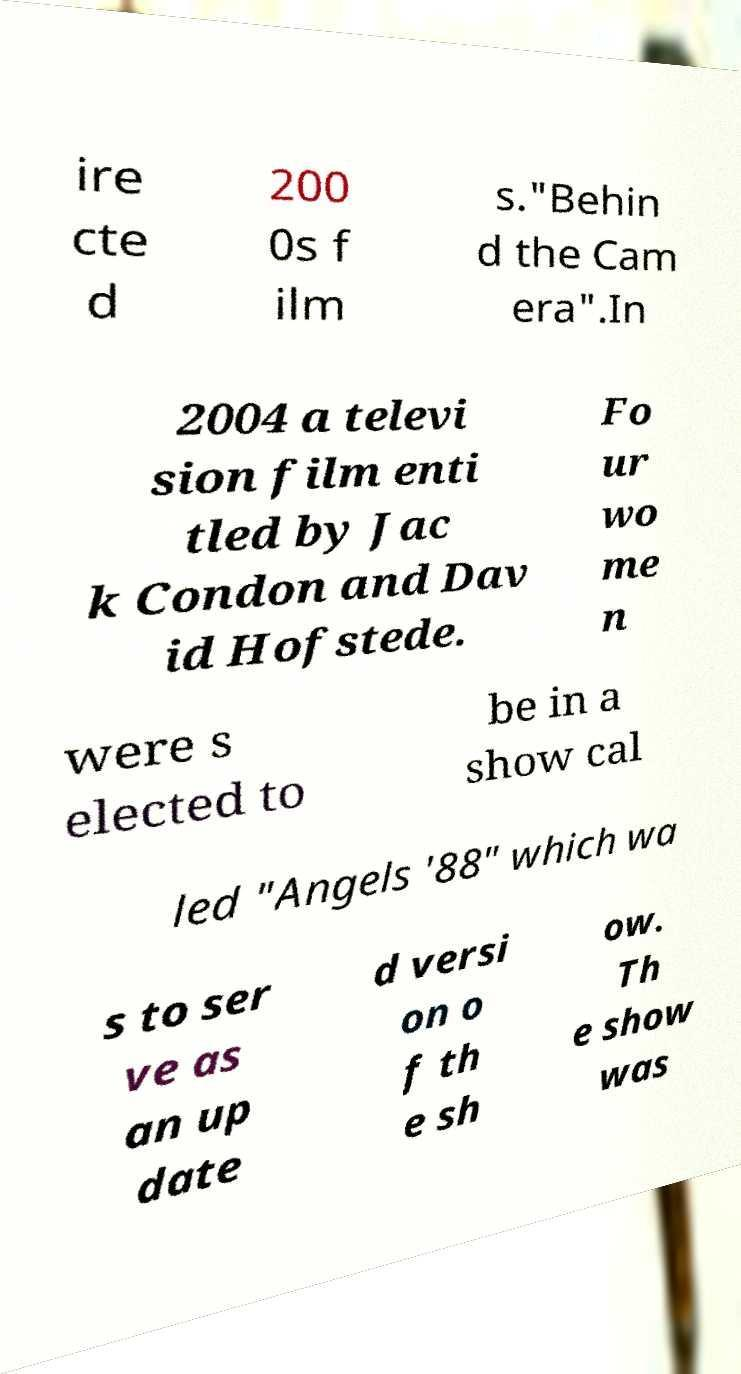What messages or text are displayed in this image? I need them in a readable, typed format. ire cte d 200 0s f ilm s."Behin d the Cam era".In 2004 a televi sion film enti tled by Jac k Condon and Dav id Hofstede. Fo ur wo me n were s elected to be in a show cal led "Angels '88" which wa s to ser ve as an up date d versi on o f th e sh ow. Th e show was 